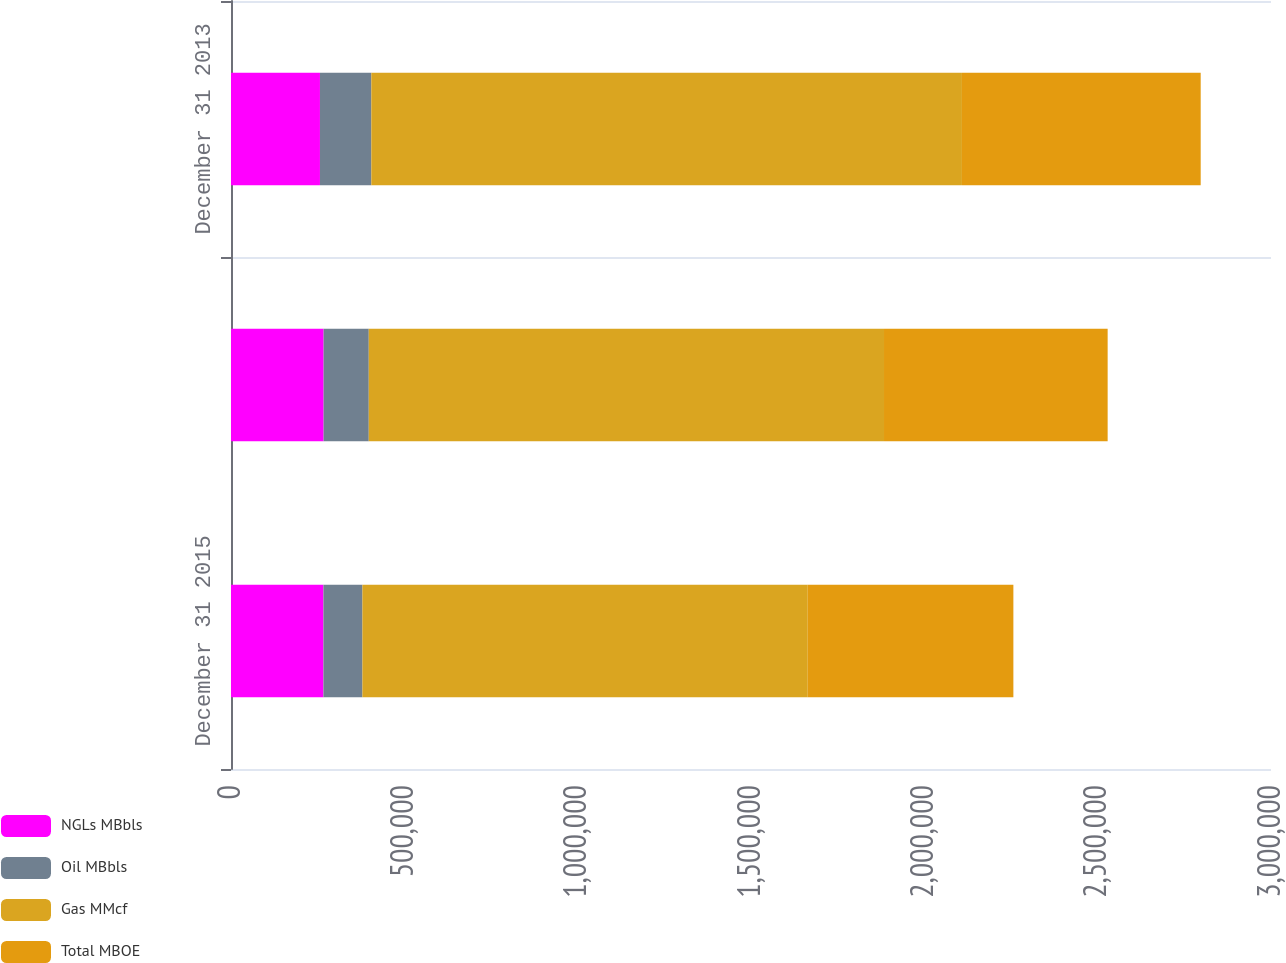Convert chart. <chart><loc_0><loc_0><loc_500><loc_500><stacked_bar_chart><ecel><fcel>December 31 2015<fcel>December 31 2014<fcel>December 31 2013<nl><fcel>NGLs MBbls<fcel>266657<fcel>267193<fcel>256638<nl><fcel>Oil MBbls<fcel>112376<fcel>130206<fcel>148161<nl><fcel>Gas MMcf<fcel>1.28468e+06<fcel>1.48629e+06<fcel>1.70367e+06<nl><fcel>Total MBOE<fcel>593146<fcel>645113<fcel>688743<nl></chart> 